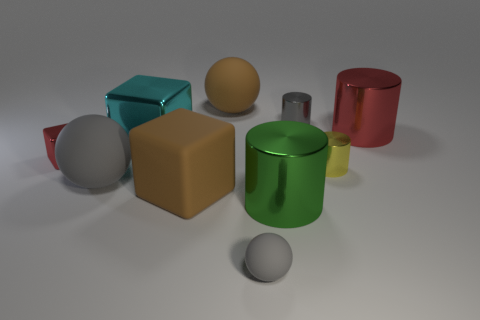Subtract all gray blocks. How many gray spheres are left? 2 Subtract all shiny cubes. How many cubes are left? 1 Subtract 1 cubes. How many cubes are left? 2 Subtract all cyan cylinders. Subtract all cyan balls. How many cylinders are left? 4 Subtract 1 cyan cubes. How many objects are left? 9 Subtract all cubes. How many objects are left? 7 Subtract all big cyan blocks. Subtract all brown matte objects. How many objects are left? 7 Add 4 large red metallic cylinders. How many large red metallic cylinders are left? 5 Add 7 big red cylinders. How many big red cylinders exist? 8 